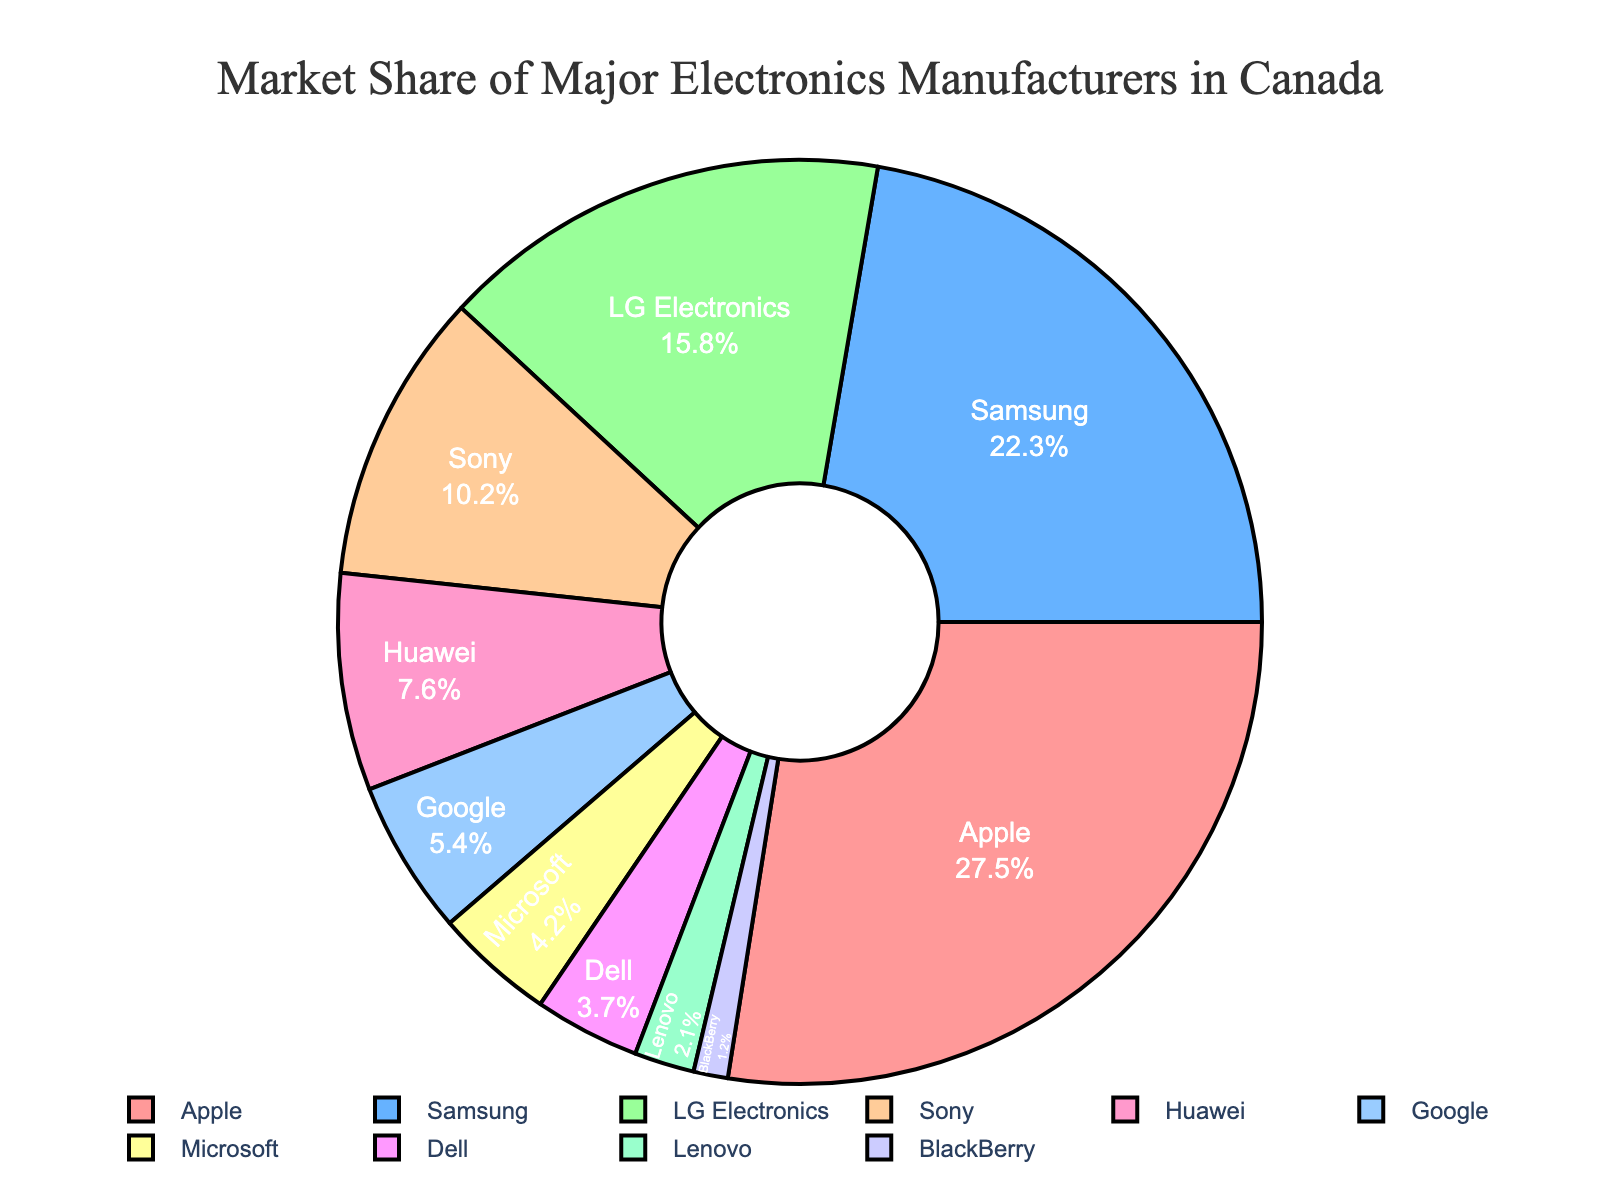What company has the highest market share? From the pie chart, the company with the largest segment is Apple. The text inside the segment shows 27.5%, which is the highest market share.
Answer: Apple What is the combined market share of Samsung and LG Electronics? Samsung has a market share of 22.3%, and LG Electronics has 15.8%. Adding these together gives 22.3% + 15.8% = 38.1%.
Answer: 38.1% How much larger is Apple's market share compared to Sony's? Apple's market share is 27.5%, and Sony's is 10.2%. Subtracting Sony's share from Apple's gives 27.5% - 10.2% = 17.3%.
Answer: 17.3% Which manufacturers have a market share less than 5%? From the pie chart, Google, Microsoft, Dell, Lenovo, and BlackBerry have shares of 5.4%, 4.2%, 3.7%, 2.1%, and 1.2% respectively. Only Microsoft, Dell, Lenovo, and BlackBerry have shares less than 5%.
Answer: Microsoft, Dell, Lenovo, BlackBerry What is the average market share of the bottom three companies? The bottom three companies are Lenovo (2.1%), BlackBerry (1.2%), and Dell (3.7%). Adding these gives 2.1% + 1.2% + 3.7% = 7%, and the average is 7% / 3 = 2.33%.
Answer: 2.33% If we combine the market shares of Apple and Huawei, what percentage of the total market would this represent? Apple's share is 27.5% and Huawei's is 7.6%. Adding these, we get 27.5% + 7.6% = 35.1%.
Answer: 35.1% Which two companies together hold more than 40% of the market share? Apple has 27.5% and Samsung has 22.3%. Adding them gives 27.5% + 22.3% = 49.8%, which is more than 40%. Thus, Apple and Samsung together hold more than 40% of the market.
Answer: Apple and Samsung What color is used to represent Google on the pie chart? The color for Google on the pie chart is a distinct shade. From visual inspection, Google's section is represented in a light purple color.
Answer: Light Purple 